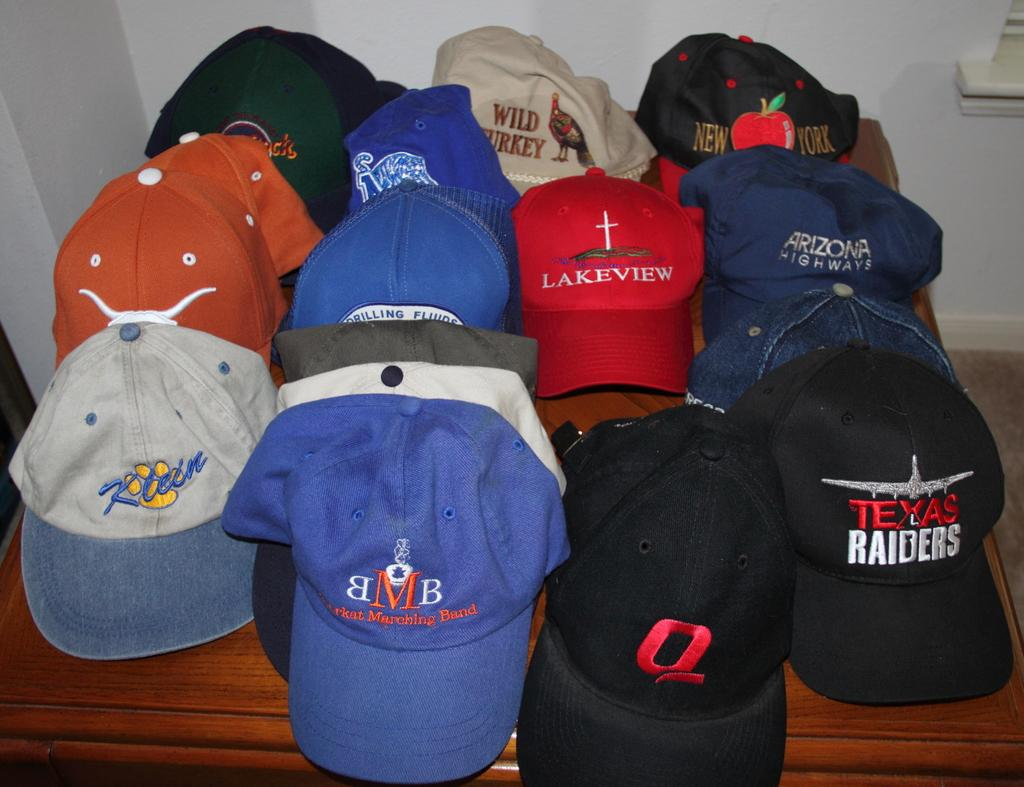Provide a one-sentence caption for the provided image. several hats with logos, such as texas raiders and wild turkey. 